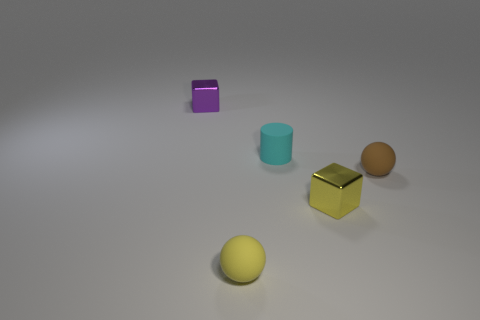Add 1 small brown spheres. How many objects exist? 6 Subtract all balls. How many objects are left? 3 Subtract all tiny brown metal balls. Subtract all spheres. How many objects are left? 3 Add 5 tiny cyan cylinders. How many tiny cyan cylinders are left? 6 Add 3 big cylinders. How many big cylinders exist? 3 Subtract 0 green cylinders. How many objects are left? 5 